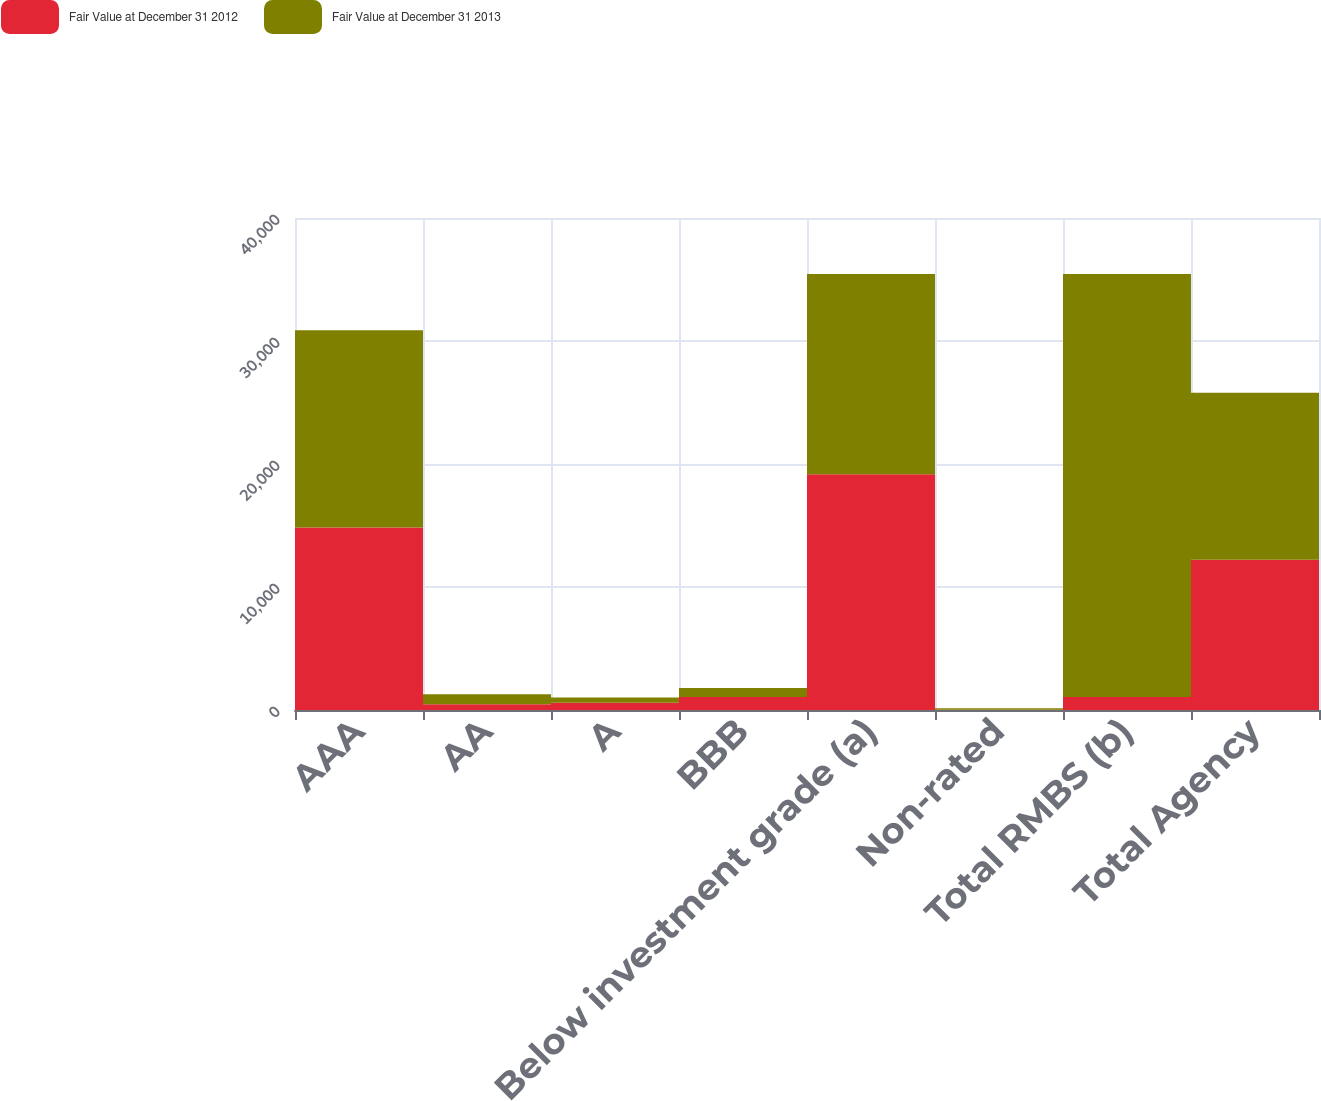Convert chart. <chart><loc_0><loc_0><loc_500><loc_500><stacked_bar_chart><ecel><fcel>AAA<fcel>AA<fcel>A<fcel>BBB<fcel>Below investment grade (a)<fcel>Non-rated<fcel>Total RMBS (b)<fcel>Total Agency<nl><fcel>Fair Value at December 31 2012<fcel>14833<fcel>477<fcel>598<fcel>1051<fcel>19163<fcel>26<fcel>1051<fcel>12216<nl><fcel>Fair Value at December 31 2013<fcel>16048<fcel>795<fcel>411<fcel>744<fcel>16283<fcel>111<fcel>34392<fcel>13574<nl></chart> 